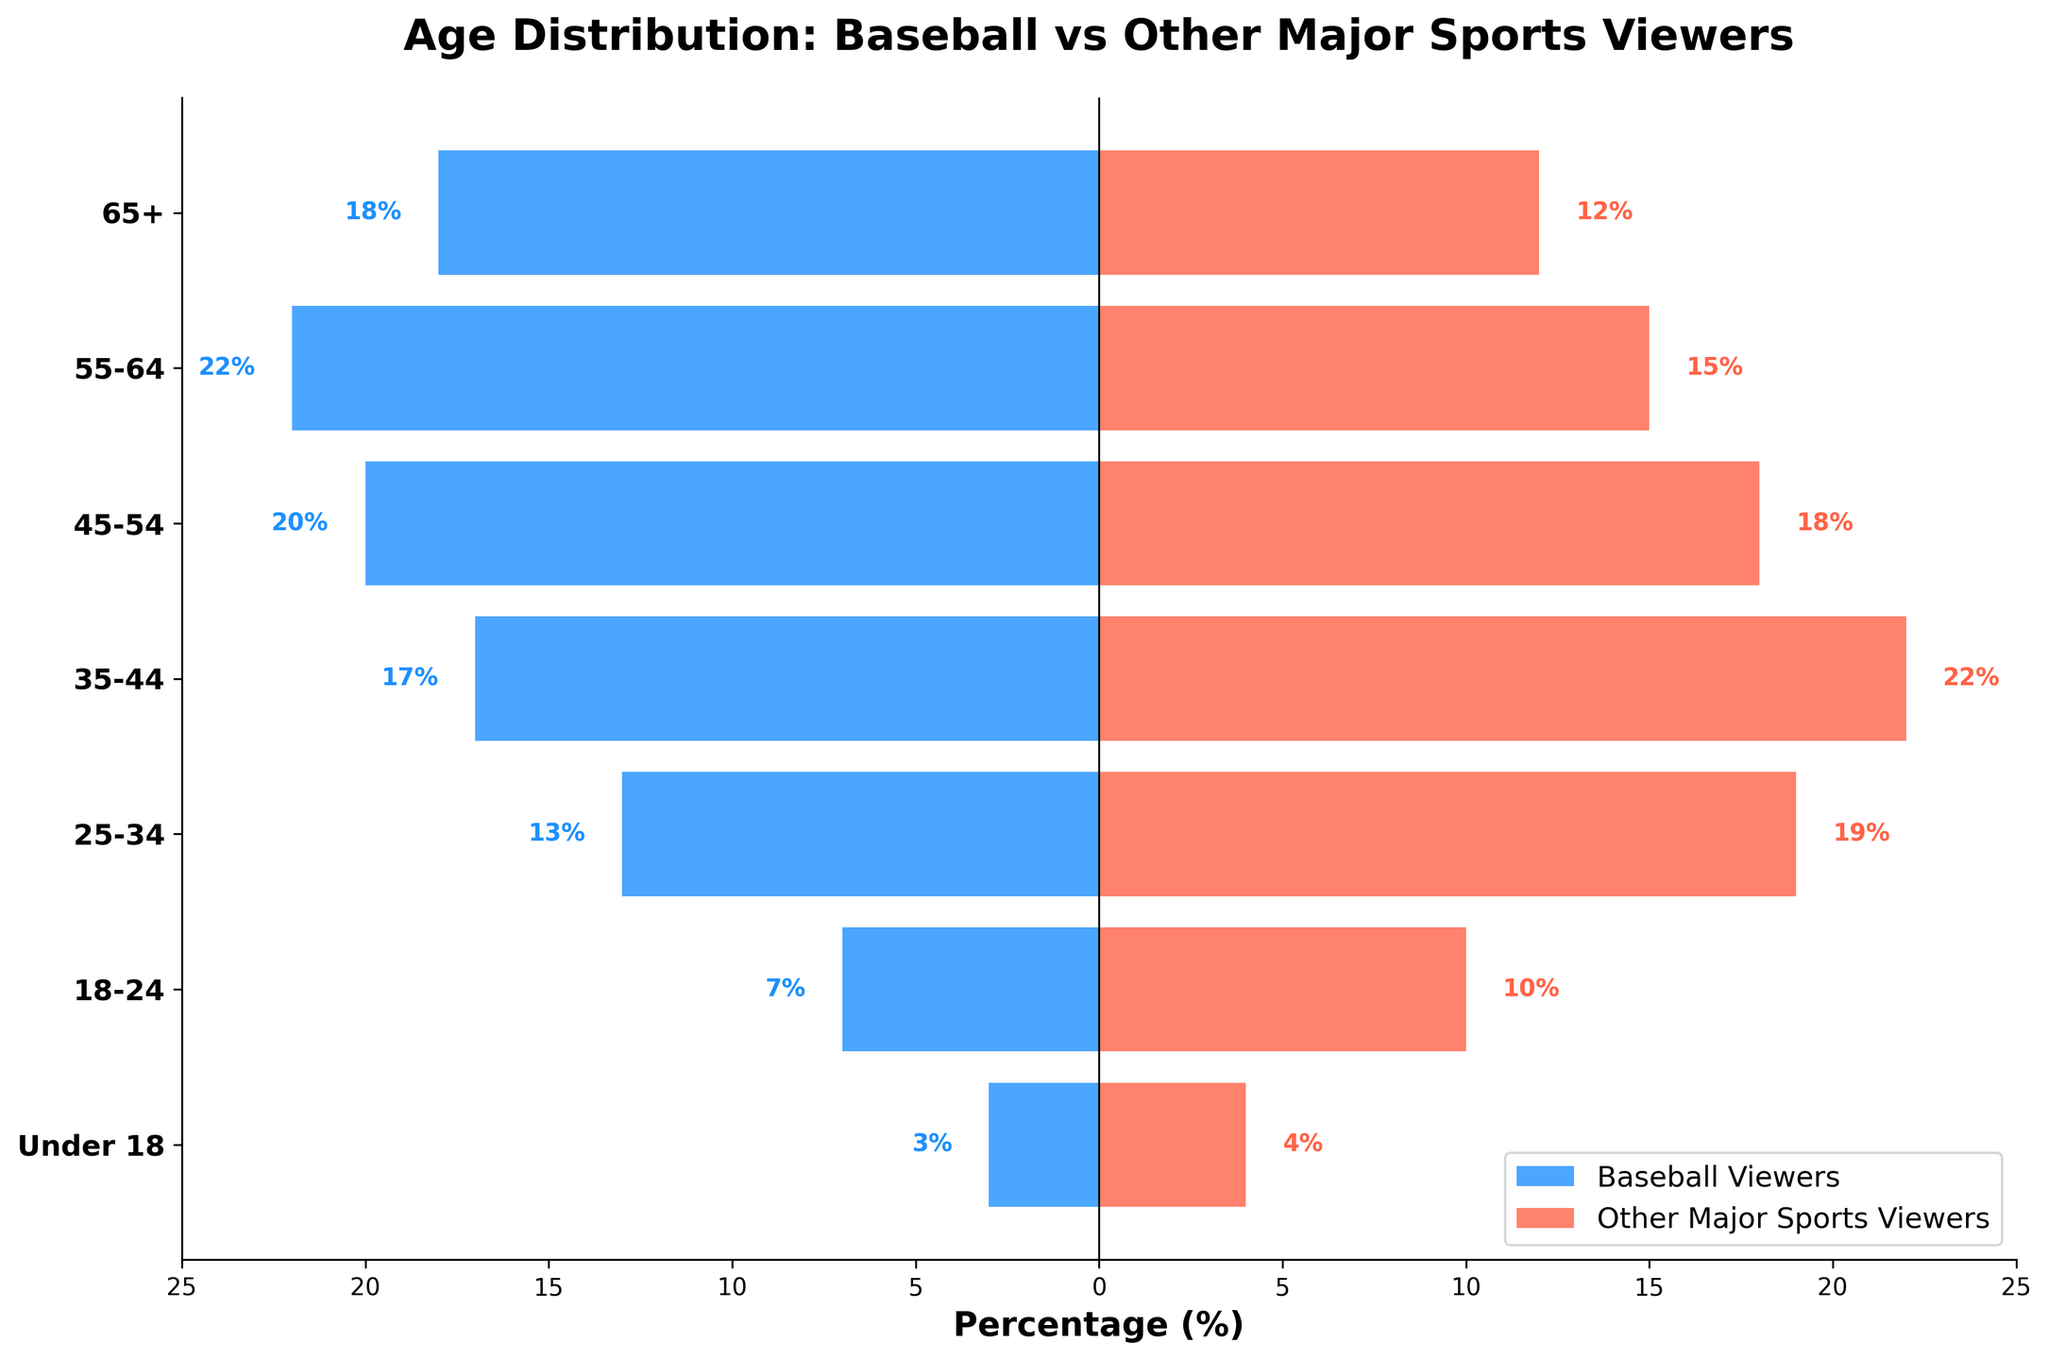What is the percentage of viewers aged 65+ for baseball compared to other major sports? To find the percentage for baseball viewers aged 65+, look at the figure and see that the bar for baseball viewers is labeled 18. For other major sports, it is labeled 12.
Answer: Baseball: 18%, Other Sports: 12% Which age group has the highest percentage of baseball viewers? Look at the highest negative bar in the figure. The age group with the highest percentage for baseball viewers is 55-64, where the negative bar reaches -22.
Answer: 55-64 Which age group is least represented among baseball viewers? Look for the smallest negative bar in the figure for baseball viewers. The age group with the smallest percentage is Under 18, with a bar reaching -3.
Answer: Under 18 How does the 35-44 age group's representation differ between baseball and other major sports viewers? Look at this age group and compare the length of the bars. The bar length for baseball viewers is -17, while for other major sports, it is 22. The percentage difference is 22 - 17, which is 5 in favor of other major sports viewers.
Answer: 5% What is the difference in total percentage between viewers aged 25-34 for baseball and other major sports? Identify the percentages for the 25-34 age group in both categories. For baseball viewers, it is -13, and for other major sports, it is 19. The difference is 19 - 13, equaling 6.
Answer: 6% Compare the percentage of viewers aged 18-24 between baseball and other major sports. Check the bars for the 18-24 age group. For baseball, the percentage is -7, and for other sports, it is 10. This shows a percentage difference of 10 - 7 = 3.
Answer: 3% Which age group has a larger percentage of viewers for other major sports as compared to baseball? Examine the bars on the right (other major sports) and left (baseball) for each age group. Age groups 35-44, 25-34, 18-24, and Under 18 each have larger percentages in other major sports compared to baseball.
Answer: 35-44, 25-34, 18-24, Under 18 Which age groups have a higher proportion of baseball viewers than other major sports viewers? Compare the lengths of the bars for each age group. For age groups 65+, 55-64, and 45-54, the negative bars (baseball) are longer, indicating a higher proportion of baseball viewers.
Answer: 65+, 55-64, 45-54 What is the total percentage of viewers aged 45+ among baseball viewers? Sum the percentages of the age groups 65+, 55-64, and 45-54. These are 18, 22, and 20, respectively. So, 18 + 22 + 20 = 60.
Answer: 60% What is the combined percentage of viewers Under 18 for both baseball and other major sports? Add the percentages for Under 18 age group in both viewer categories. For baseball, it is -3, and for other sports, it is 4. So, -3 + 4 = 4 - 3 = 1.
Answer: 1% 